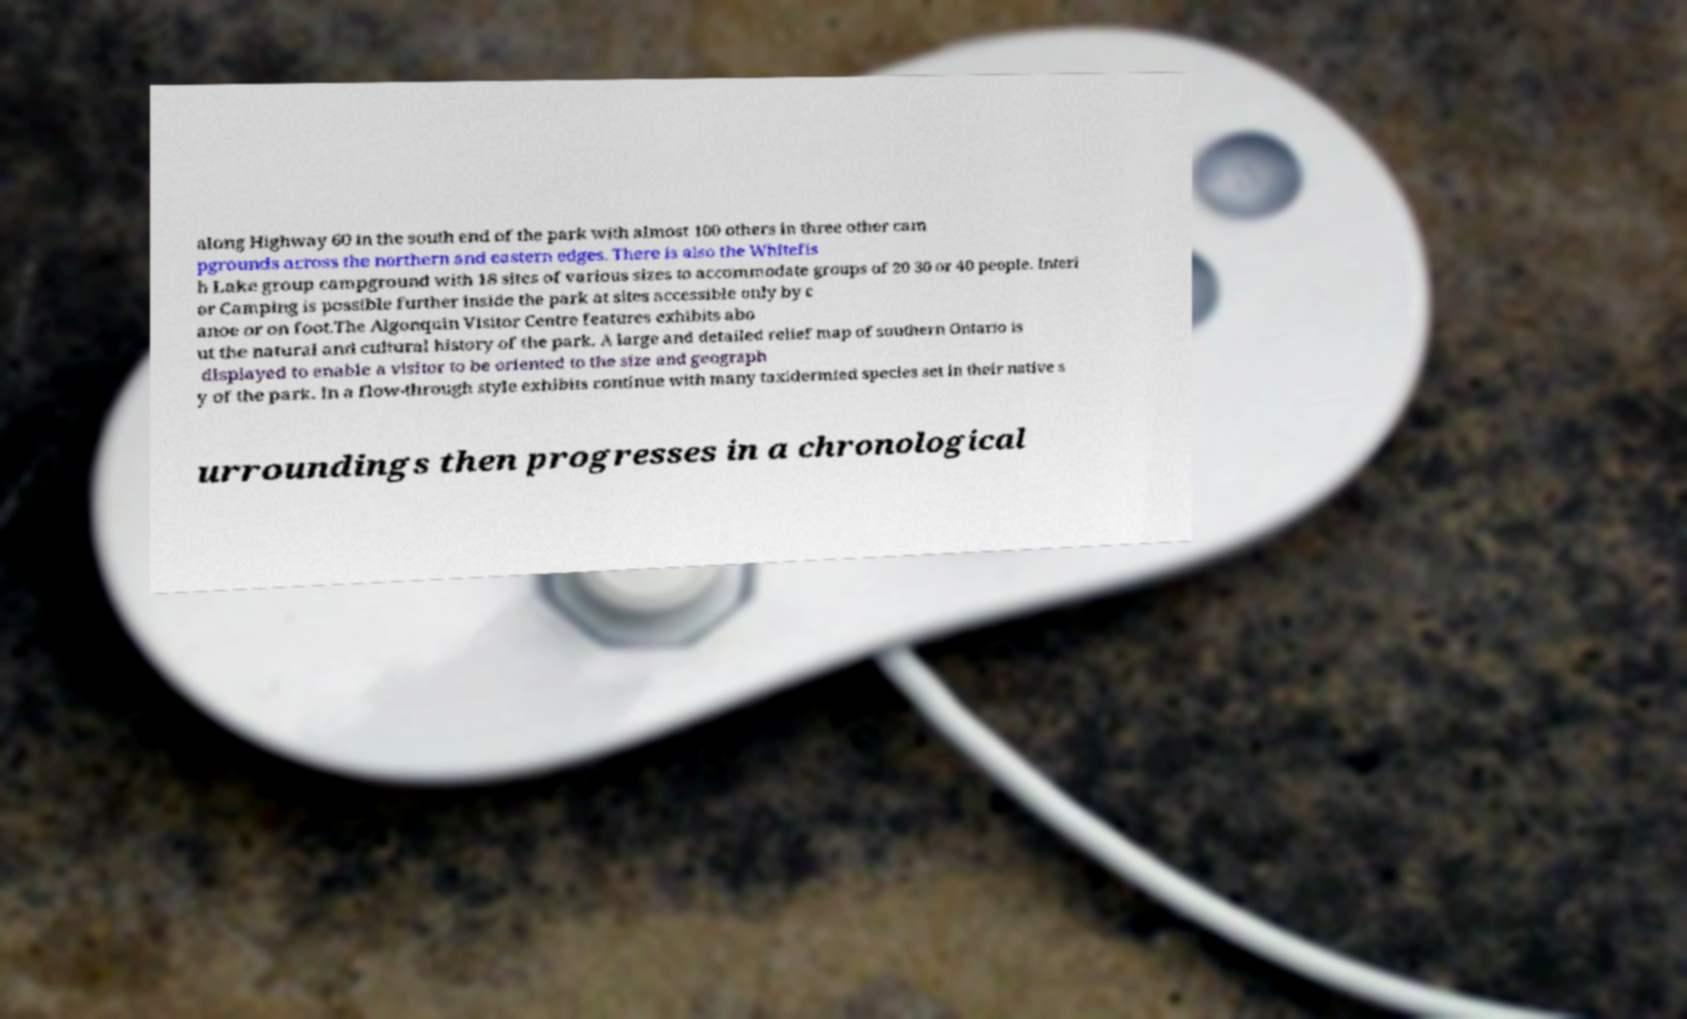Please identify and transcribe the text found in this image. along Highway 60 in the south end of the park with almost 100 others in three other cam pgrounds across the northern and eastern edges. There is also the Whitefis h Lake group campground with 18 sites of various sizes to accommodate groups of 20 30 or 40 people. Interi or Camping is possible further inside the park at sites accessible only by c anoe or on foot.The Algonquin Visitor Centre features exhibits abo ut the natural and cultural history of the park. A large and detailed relief map of southern Ontario is displayed to enable a visitor to be oriented to the size and geograph y of the park. In a flow-through style exhibits continue with many taxidermied species set in their native s urroundings then progresses in a chronological 